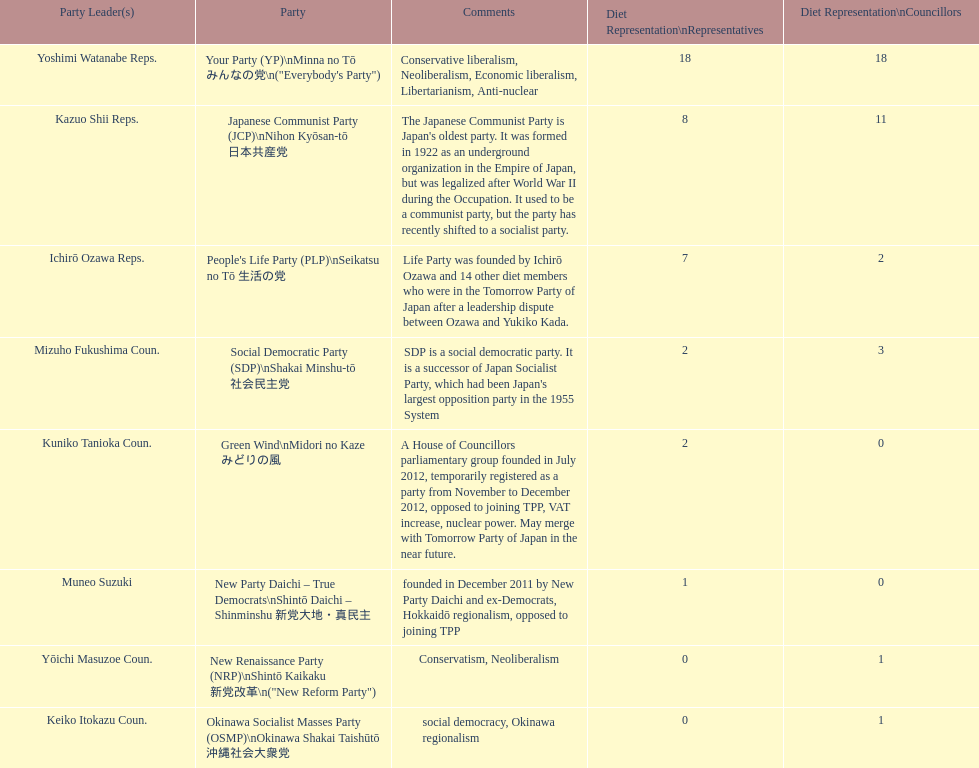How many representatives come from the green wind party? 2. Could you parse the entire table? {'header': ['Party Leader(s)', 'Party', 'Comments', 'Diet Representation\\nRepresentatives', 'Diet Representation\\nCouncillors'], 'rows': [['Yoshimi Watanabe Reps.', 'Your Party (YP)\\nMinna no Tō みんなの党\\n("Everybody\'s Party")', 'Conservative liberalism, Neoliberalism, Economic liberalism, Libertarianism, Anti-nuclear', '18', '18'], ['Kazuo Shii Reps.', 'Japanese Communist Party (JCP)\\nNihon Kyōsan-tō 日本共産党', "The Japanese Communist Party is Japan's oldest party. It was formed in 1922 as an underground organization in the Empire of Japan, but was legalized after World War II during the Occupation. It used to be a communist party, but the party has recently shifted to a socialist party.", '8', '11'], ['Ichirō Ozawa Reps.', "People's Life Party (PLP)\\nSeikatsu no Tō 生活の党", 'Life Party was founded by Ichirō Ozawa and 14 other diet members who were in the Tomorrow Party of Japan after a leadership dispute between Ozawa and Yukiko Kada.', '7', '2'], ['Mizuho Fukushima Coun.', 'Social Democratic Party (SDP)\\nShakai Minshu-tō 社会民主党', "SDP is a social democratic party. It is a successor of Japan Socialist Party, which had been Japan's largest opposition party in the 1955 System", '2', '3'], ['Kuniko Tanioka Coun.', 'Green Wind\\nMidori no Kaze みどりの風', 'A House of Councillors parliamentary group founded in July 2012, temporarily registered as a party from November to December 2012, opposed to joining TPP, VAT increase, nuclear power. May merge with Tomorrow Party of Japan in the near future.', '2', '0'], ['Muneo Suzuki', 'New Party Daichi – True Democrats\\nShintō Daichi – Shinminshu 新党大地・真民主', 'founded in December 2011 by New Party Daichi and ex-Democrats, Hokkaidō regionalism, opposed to joining TPP', '1', '0'], ['Yōichi Masuzoe Coun.', 'New Renaissance Party (NRP)\\nShintō Kaikaku 新党改革\\n("New Reform Party")', 'Conservatism, Neoliberalism', '0', '1'], ['Keiko Itokazu Coun.', 'Okinawa Socialist Masses Party (OSMP)\\nOkinawa Shakai Taishūtō 沖縄社会大衆党', 'social democracy, Okinawa regionalism', '0', '1']]} 